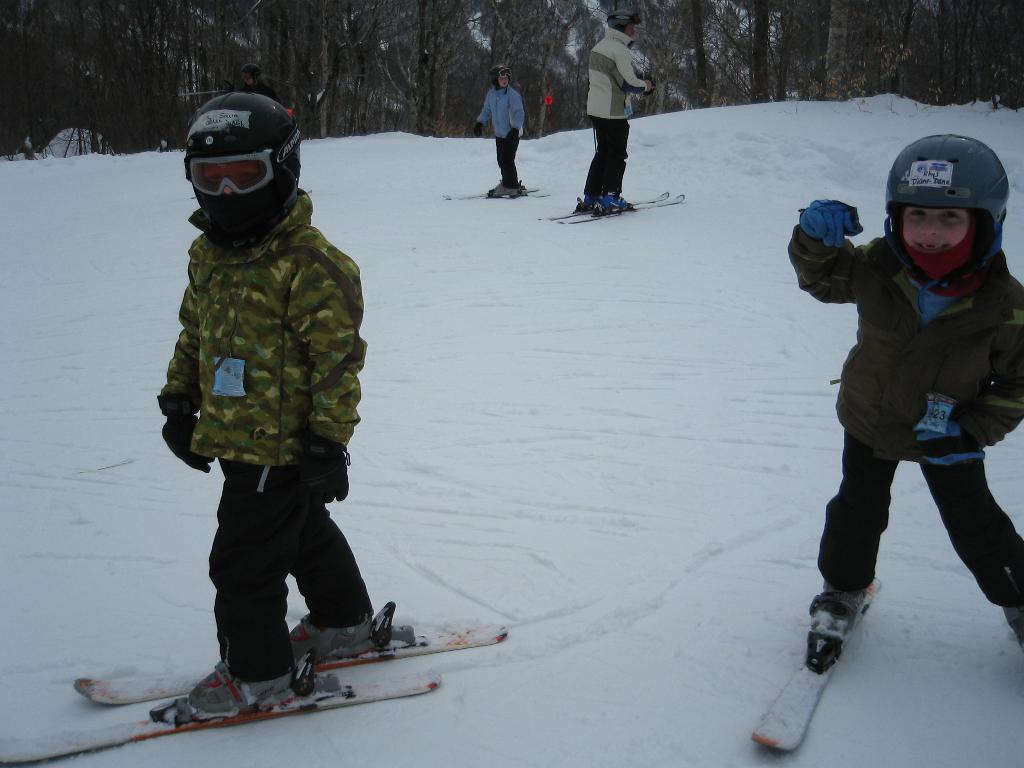How many people are in the image? There are five people in the image. What activity are the people engaged in? The people are skating. What equipment are the people using for skating? The people are using ski boards for skating. What is the surface on which the skating is taking place? The skating is taking place on snow. What can be seen in the background of the image? There are trees visible in the background of the image. What type of insurance policy do the people have while skating in the image? There is no information about insurance policies in the image; it only shows people skating on snow. 